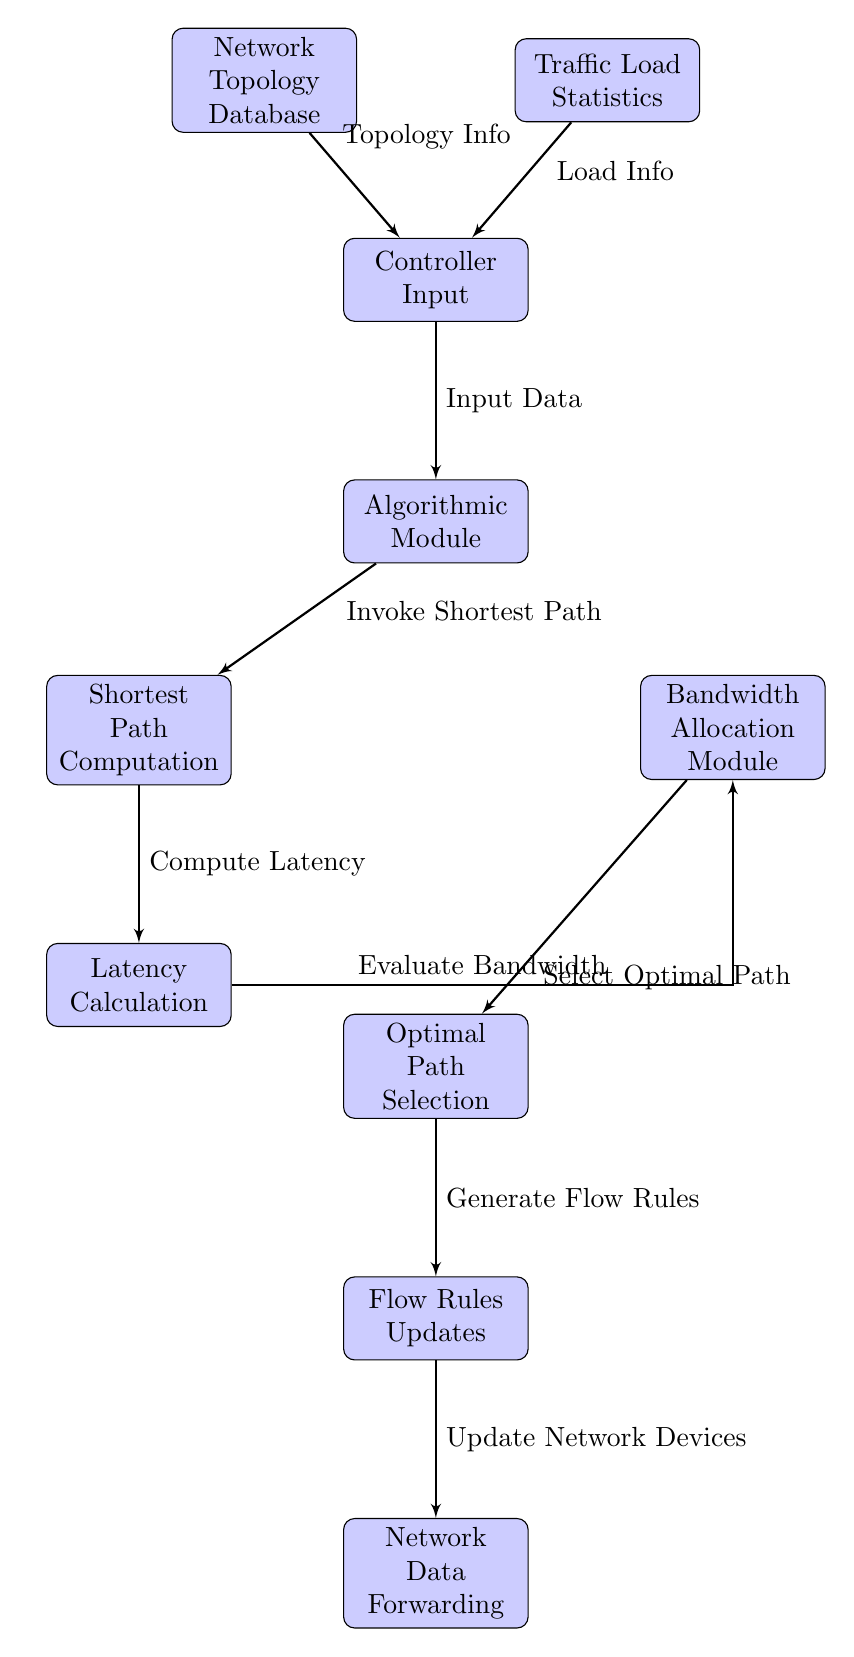What's the total number of blocks in the diagram? The diagram consists of ten blocks arranged in a flow. Each block is represented as a rectangular node in the TikZ code. Counting these, we confirm that there are ten blocks in total.
Answer: 10 What is the first block in the flow? In the diagram, the first block is named "Network Topology Database," which is positioned at the top of the flow. Its placement signifies the initial step in the data processing sequence.
Answer: Network Topology Database Which two blocks provide inputs to the Controller Input block? The "Network Topology Database" and "Traffic Load Statistics" blocks feed into the "Controller Input" block, supplying essential data. This relationship is indicated by the arrows drawn from both blocks to the Controller Input.
Answer: Network Topology Database, Traffic Load Statistics What is the output of the Algorithmic Module block? The Algorithmic Module block outputs "Invoke Shortest Path," which corresponds to the function it triggers in the subsequent Shortest Path Computation block. This is shown by the arrow leading from the Algorithmic Module to the Shortest Path Computation.
Answer: Invoke Shortest Path How many steps involve calculating latency? The latency calculation involves one dedicated block labeled "Latency Calculation." It directly follows the "Shortest Path Computation" block, indicating that latency is computed in a single step within this process.
Answer: 1 What comes after the Bandwidth Allocation Module block? After the Bandwidth Allocation Module block, the next step in the process is the "Optimal Path Selection" block. This arrangement signifies the sequence in which the bandwidth evaluation leads to the selection of the best routing path.
Answer: Optimal Path Selection What type of information do the inputs of the Controller Input block contain? The inputs to the Controller Input block consist of "Topology Info" and "Load Info." This dual input highlights the necessary data types for effective routing decisions within the network structure.
Answer: Topology Info, Load Info Which block is responsible for updating network devices? The "Flow Rules Updates" block is responsible for updating network devices, as indicated by its connection leading to the final block "Network Data Forwarding." This designation demonstrates its role in implementing established flow rules.
Answer: Flow Rules Updates 